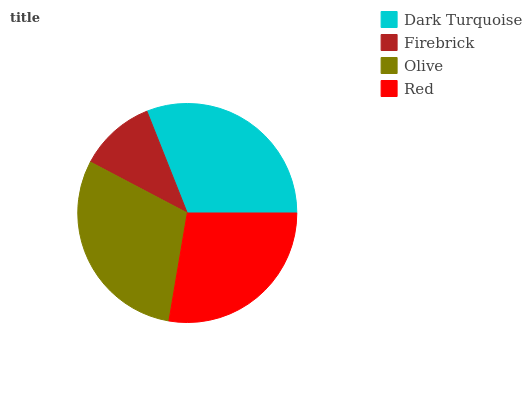Is Firebrick the minimum?
Answer yes or no. Yes. Is Dark Turquoise the maximum?
Answer yes or no. Yes. Is Olive the minimum?
Answer yes or no. No. Is Olive the maximum?
Answer yes or no. No. Is Olive greater than Firebrick?
Answer yes or no. Yes. Is Firebrick less than Olive?
Answer yes or no. Yes. Is Firebrick greater than Olive?
Answer yes or no. No. Is Olive less than Firebrick?
Answer yes or no. No. Is Olive the high median?
Answer yes or no. Yes. Is Red the low median?
Answer yes or no. Yes. Is Firebrick the high median?
Answer yes or no. No. Is Olive the low median?
Answer yes or no. No. 